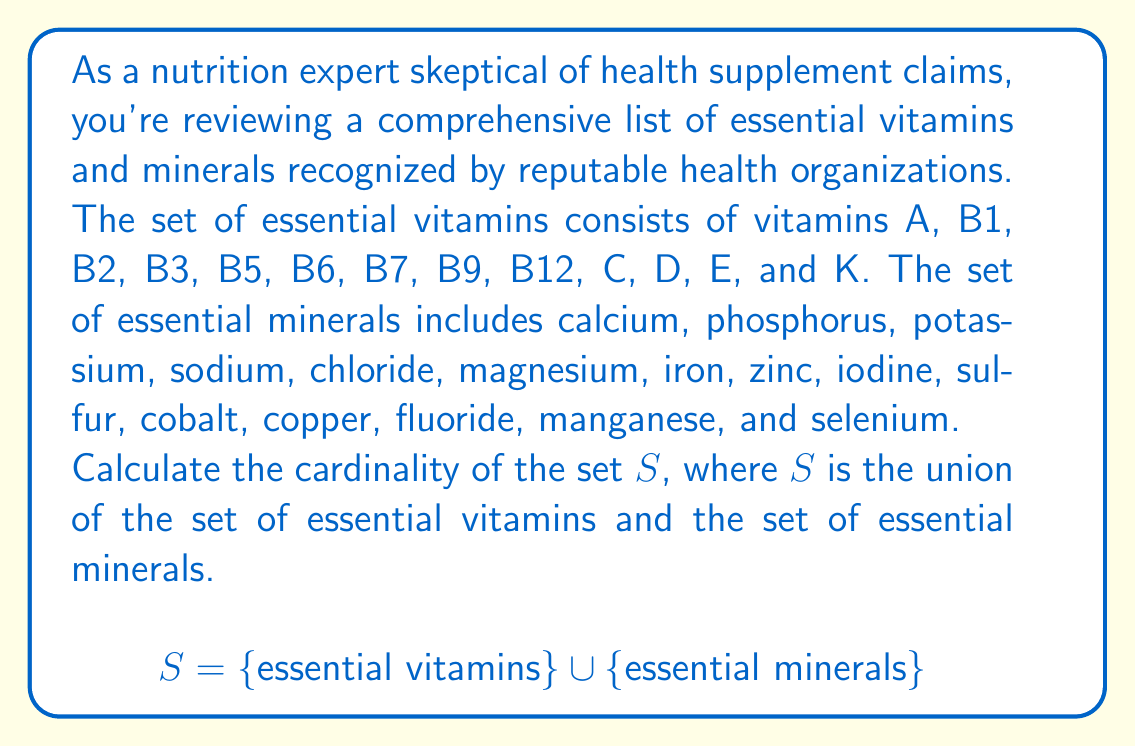Can you solve this math problem? To solve this problem, we'll follow these steps:

1) First, let's define our sets:
   Let $V$ be the set of essential vitamins
   Let $M$ be the set of essential minerals

2) Count the elements in each set:
   $|V| = 13$ (vitamins A, B1, B2, B3, B5, B6, B7, B9, B12, C, D, E, and K)
   $|M| = 15$ (calcium, phosphorus, potassium, sodium, chloride, magnesium, iron, zinc, iodine, sulfur, cobalt, copper, fluoride, manganese, and selenium)

3) We need to find $|S|$, where $S = V \cup M$

4) In set theory, for any two sets A and B:
   $|A \cup B| = |A| + |B| - |A \cap B|$

5) In our case, $V$ and $M$ are disjoint sets (no element is both a vitamin and a mineral), so $|V \cap M| = 0$

6) Therefore:
   $|S| = |V \cup M| = |V| + |M| - |V \cap M| = 13 + 15 - 0 = 28$

Thus, the cardinality of set $S$ is 28.
Answer: $|S| = 28$ 